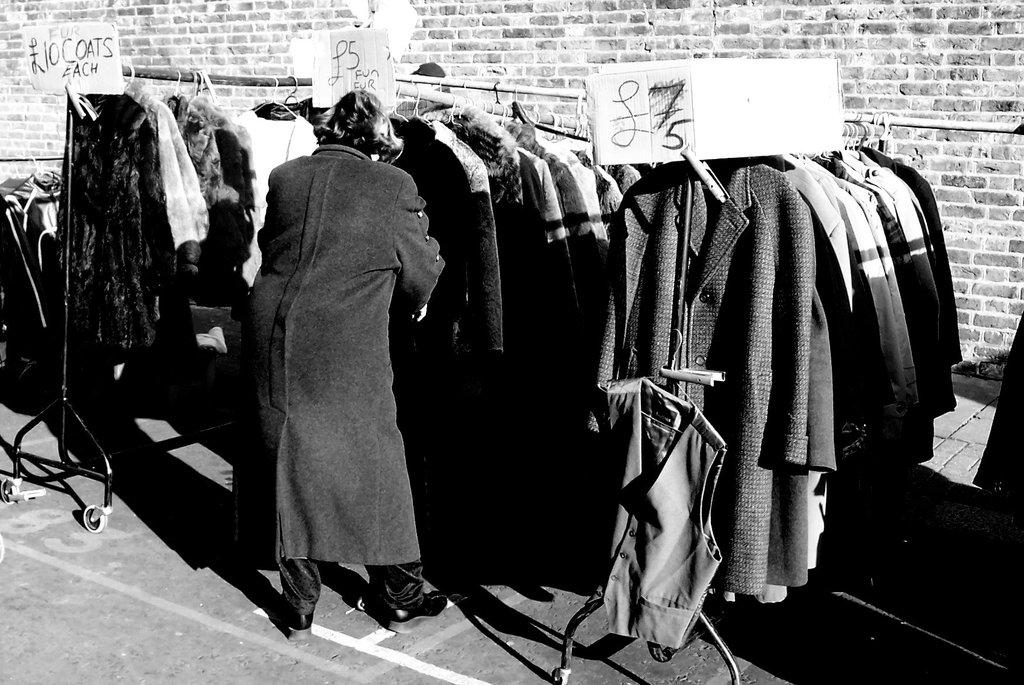What can be seen on the boards in the image? There are boards with text in the image. What type of clothing is present in the image? There are costumes in the image. What are the stands used for in the image? The stands are present in the image, but their purpose is not specified. What is the background of the image? There is a wall in the image. What type of cakes is your dad making in the image? There is no dad or cakes present in the image. What idea does the text on the boards represent in the image? The text on the boards is not specified, so it is impossible to determine the idea it represents. 